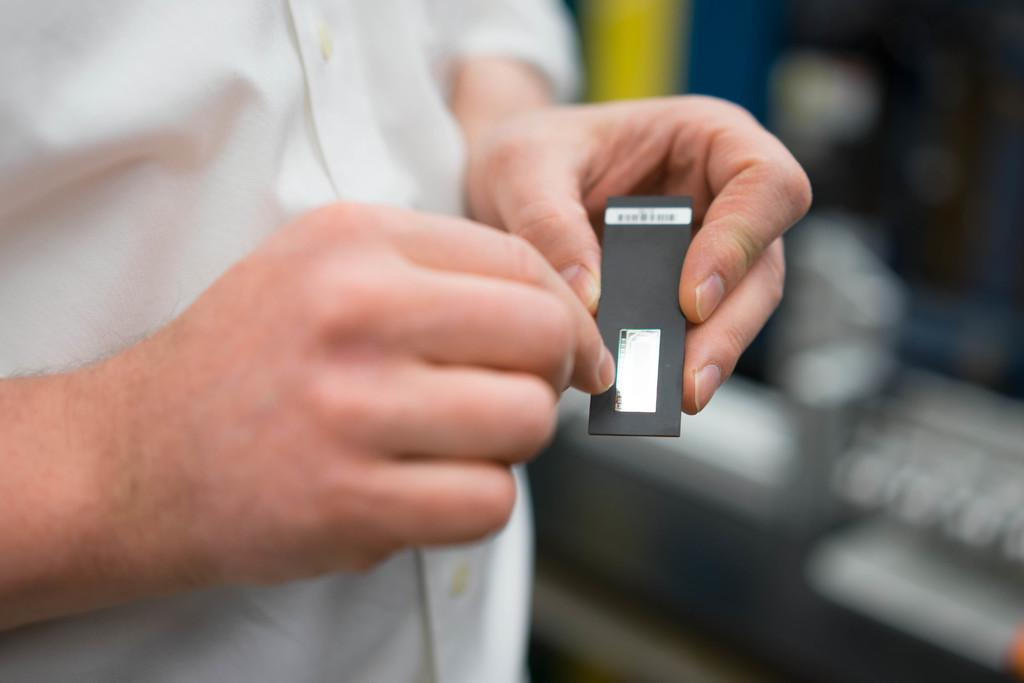What is the position of the person in the image? There is a person standing on the bottom left side of the image. What is the person holding in his hand? The person is holding something in his hand. Can you describe the background of the image? The background of the image is blurred. What type of chess piece is the person holding in the image? There is no chess piece present in the image. Is the person's father also visible in the image? The provided facts do not mention the person's father, so we cannot determine if he is present in the image. 